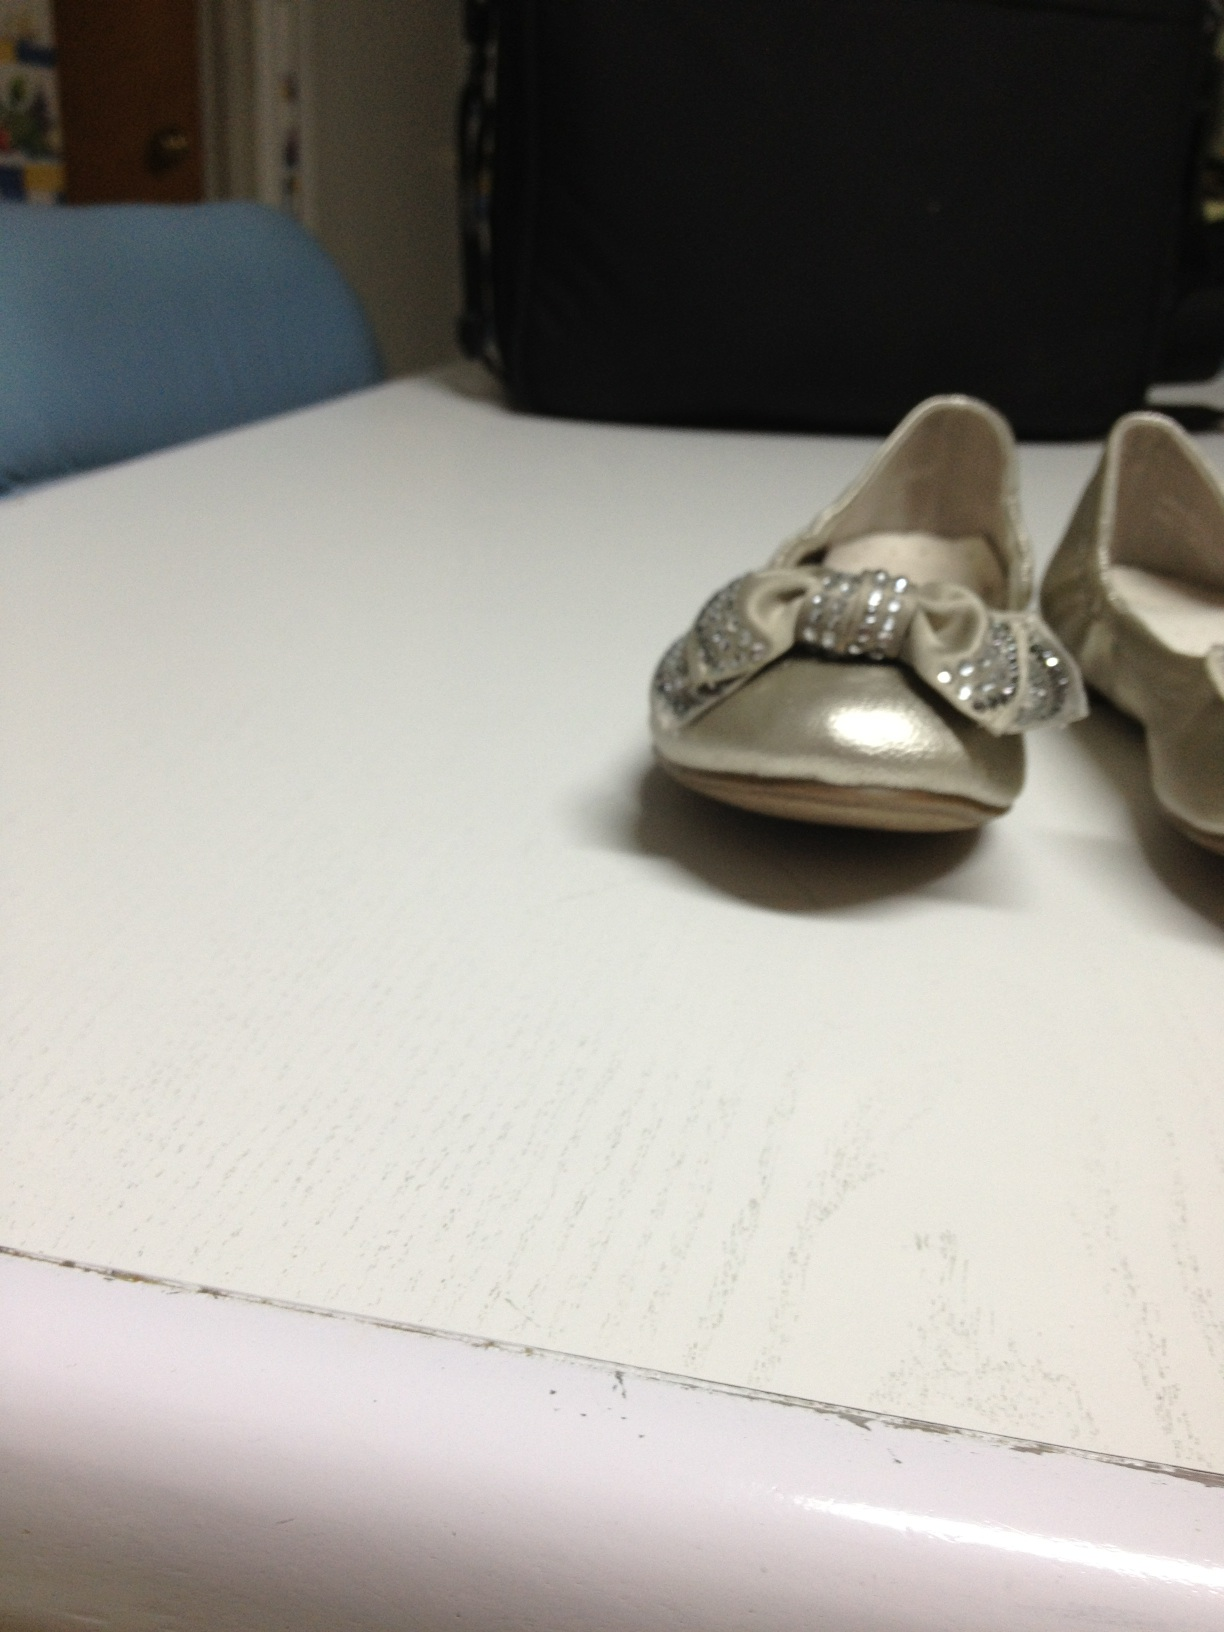Create a practical scenario where these shoes might play a crucial role. One cold winter evening, as the village prepared for the annual Winter Festival, young Emily was excited to attend the event in her new silver shoes with sparkling bows. As the festivities began, a sudden power outage plunged the village square into darkness. In the confusion, Emily's shiny shoes caught the attention of an elderly couple who had lost their way. The reflection of the festive lights on her shoes guided them back to the warmth of the community hall, proving that even the smallest details can lead to acts of kindness and connection. 